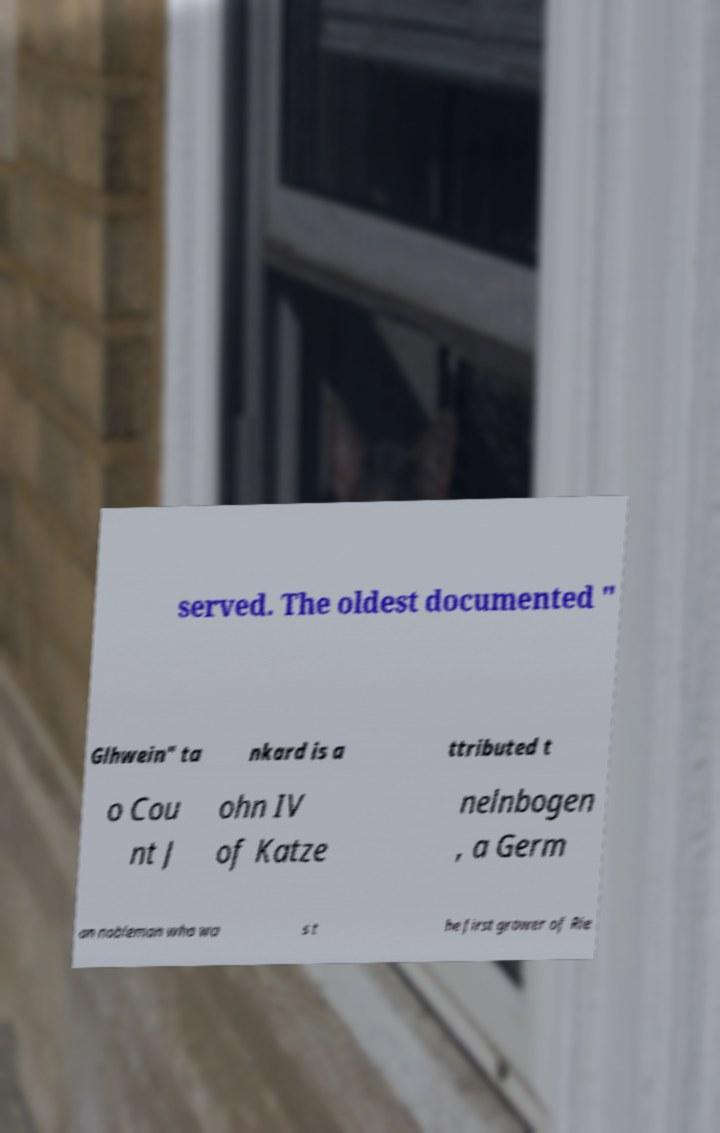For documentation purposes, I need the text within this image transcribed. Could you provide that? served. The oldest documented " Glhwein" ta nkard is a ttributed t o Cou nt J ohn IV of Katze nelnbogen , a Germ an nobleman who wa s t he first grower of Rie 